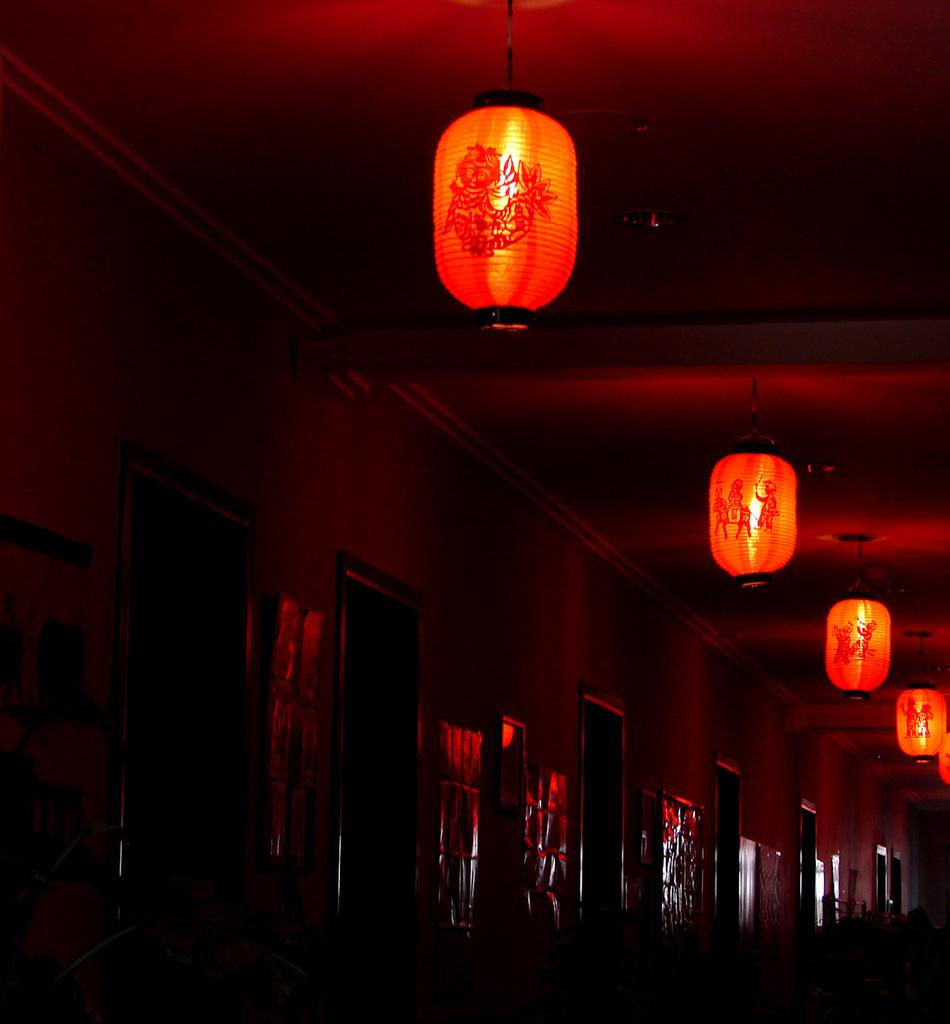What type of lighting fixtures are present in the image? There are lantern lamps in the image. What type of oatmeal is being served in the image? There is no oatmeal present in the image; it features lantern lamps. What color is the celery in the image? There is no celery present in the image; it features lantern lamps. 